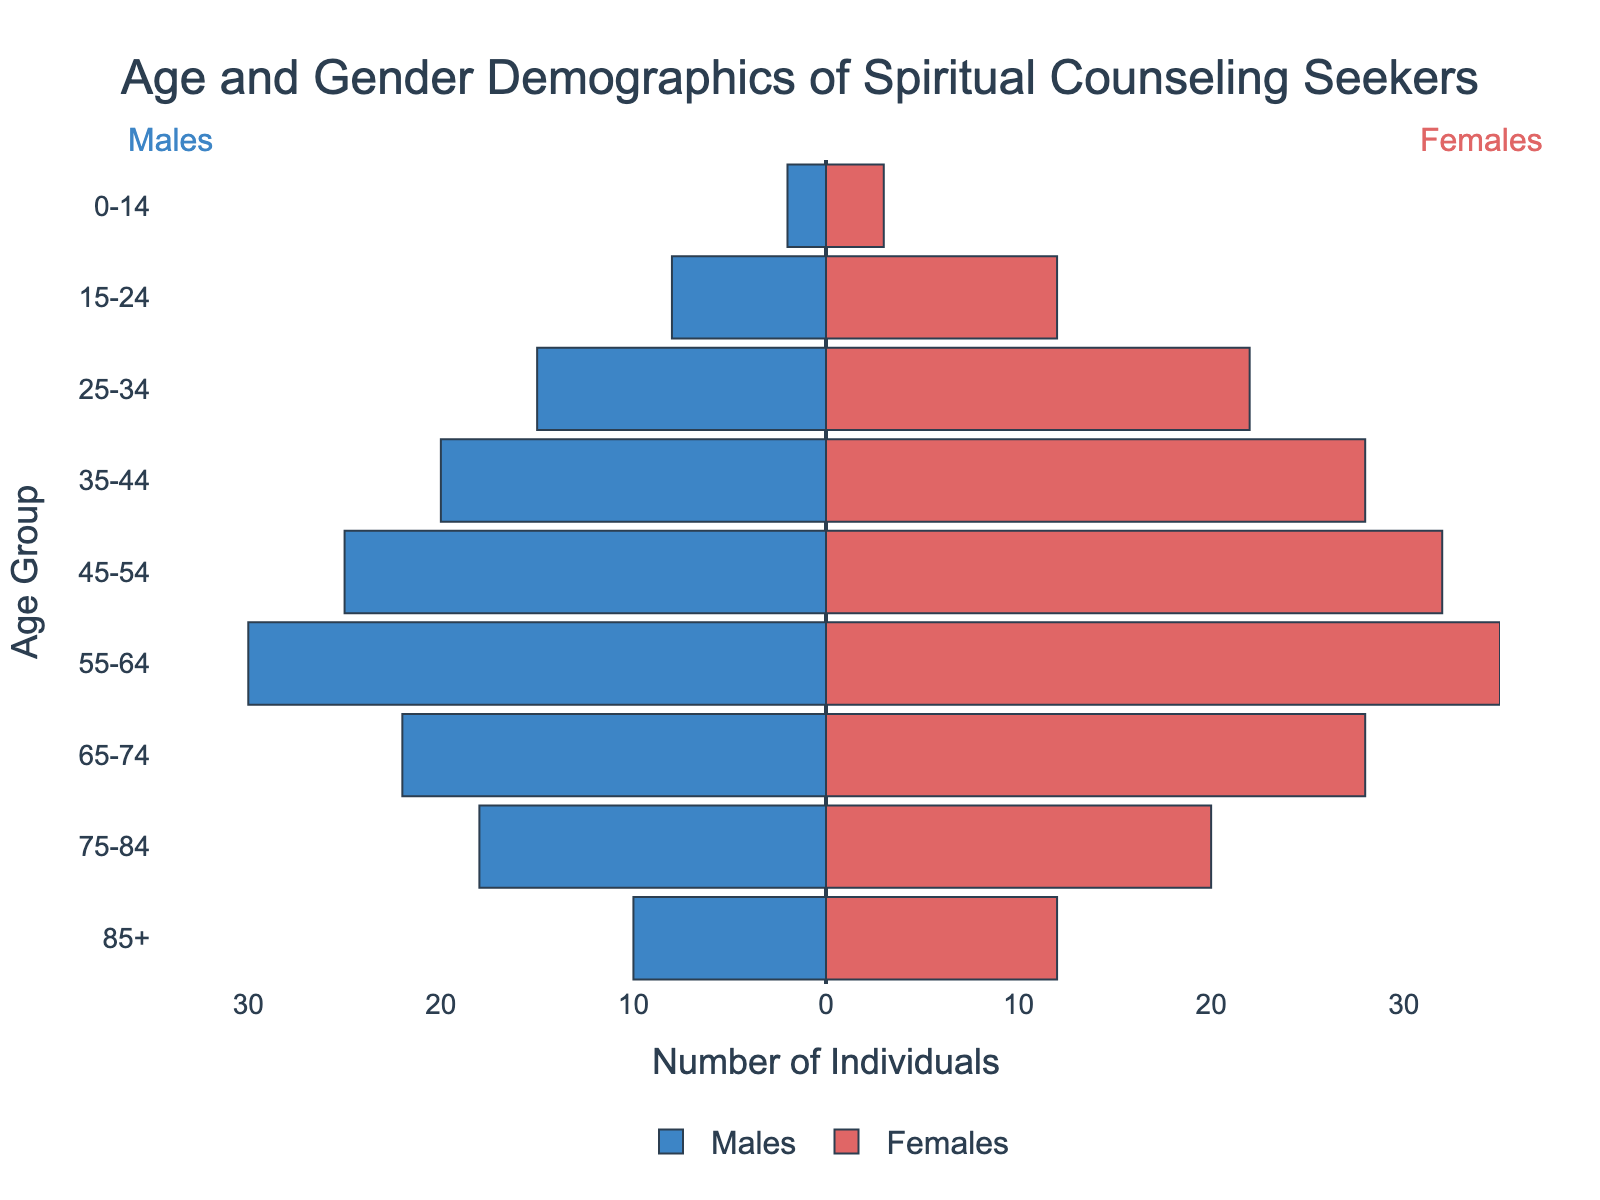What is the title of the figure? The title of the figure is prominently displayed at the top center of the plot in bold text.
Answer: Age and Gender Demographics of Spiritual Counseling Seekers What age group has the highest number of individuals seeking spiritual counseling for both genders combined? We need to look for the age group where the sum of males and females is the highest. The 55-64 age group has 30 males and 35 females, totaling 65 individuals.
Answer: 55-64 How many more females are there than males in the 25-34 age group? The number of females in the 25-34 age group is 22, and the number of males is 15. The difference is 22 - 15.
Answer: 7 Which gender has more individuals in the 75-84 age group, and by how many? The number of females in the 75-84 age group is 20, and the number of males is 18. The difference is 20 - 18.
Answer: Females by 2 What is the smallest age group and its corresponding counts for both genders? The smallest age group, based on total counts, is the 0-14 age group, with 2 males and 3 females, totaling 5.
Answer: 0-14 with 2 males and 3 females What is the total number of individuals seeking spiritual counseling across all age groups? The total is obtained by summing all individual counts for males and females across all age groups: 2 + 8 + 15 + 20 + 25 + 30 + 22 + 18 + 10 + 3 + 12 + 22 + 28 + 32 + 35 + 28 + 20 + 12.
Answer: 325 Do any age groups have an equal number of males and females? We check each age group and find no age group where the counts of males and females are equal.
Answer: No 